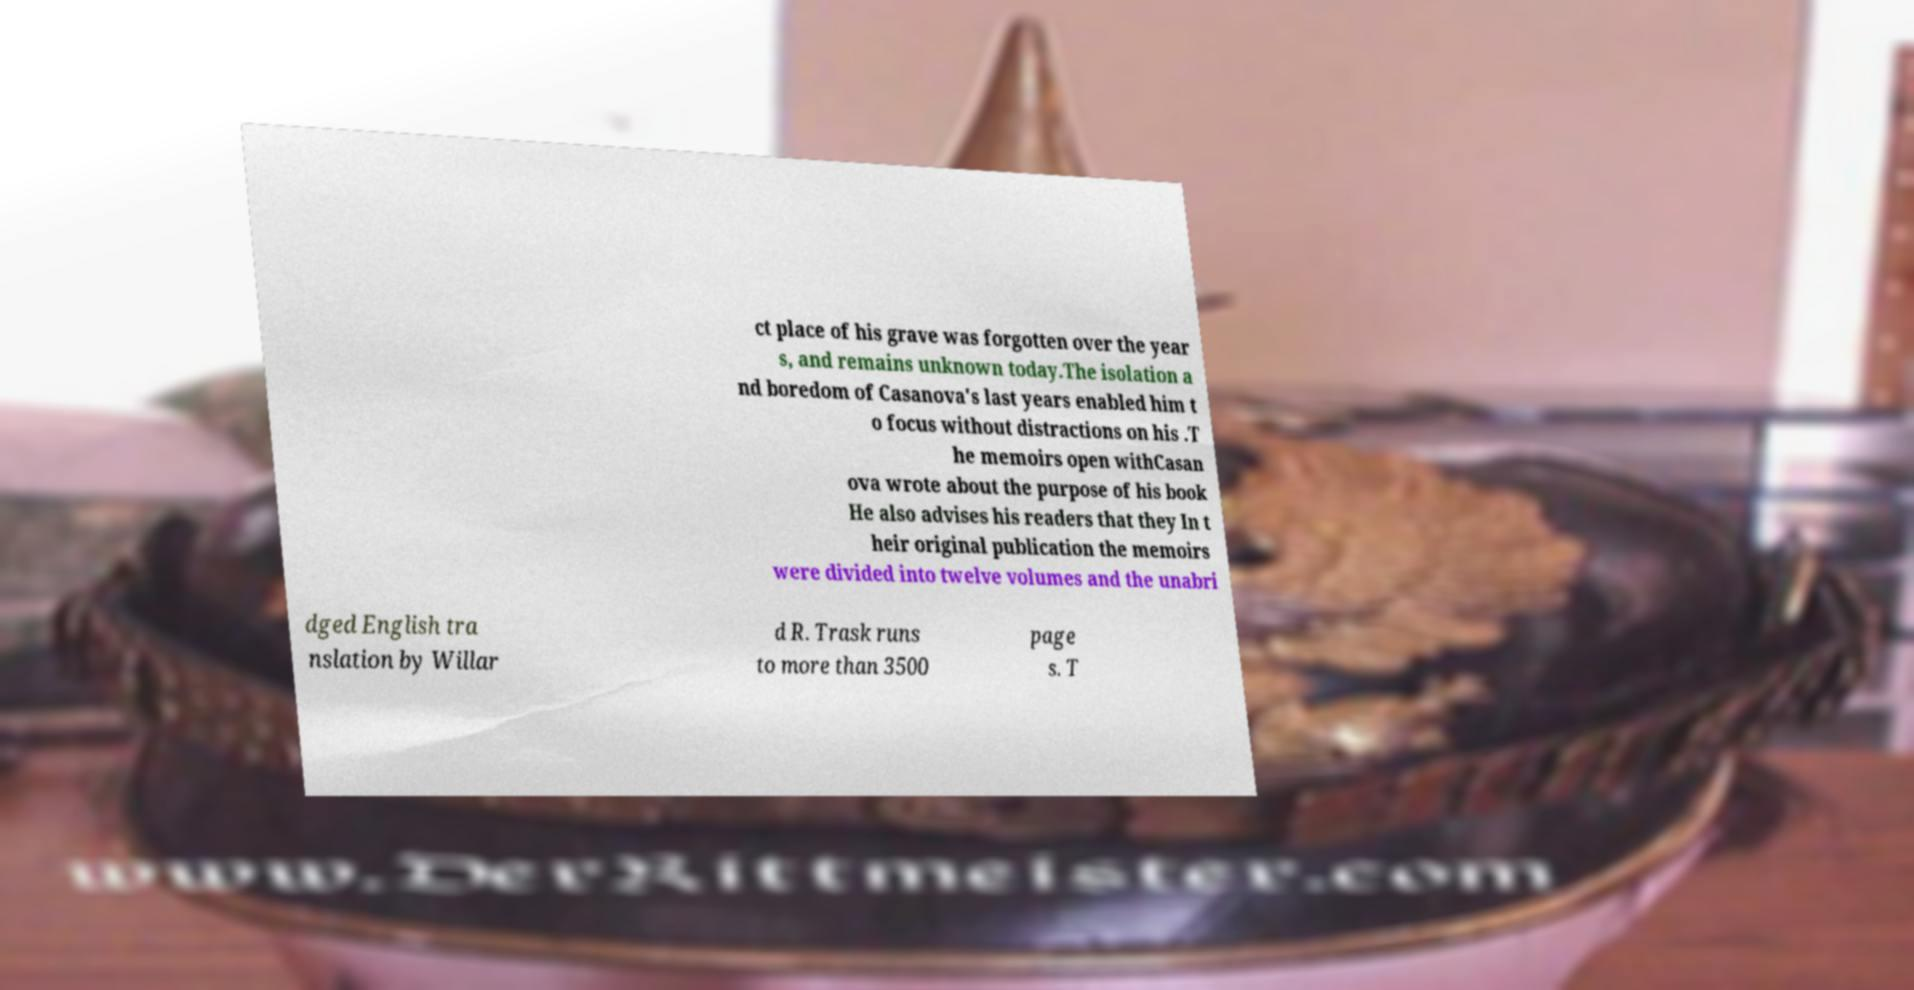Please identify and transcribe the text found in this image. ct place of his grave was forgotten over the year s, and remains unknown today.The isolation a nd boredom of Casanova's last years enabled him t o focus without distractions on his .T he memoirs open withCasan ova wrote about the purpose of his book He also advises his readers that they In t heir original publication the memoirs were divided into twelve volumes and the unabri dged English tra nslation by Willar d R. Trask runs to more than 3500 page s. T 